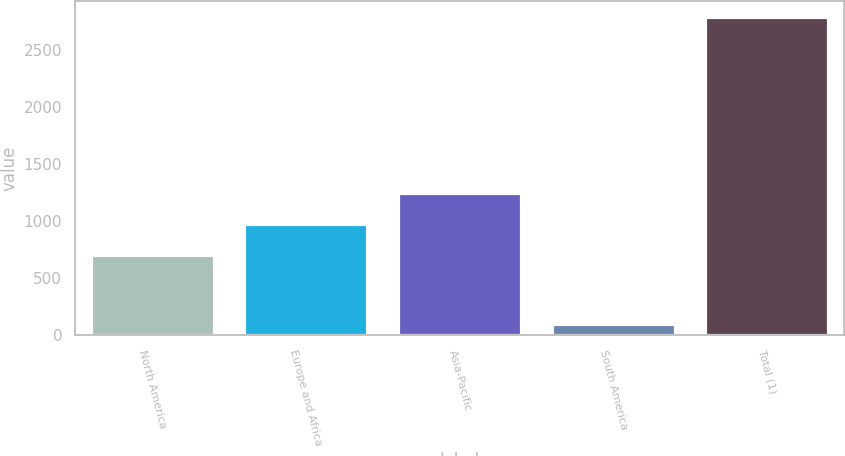Convert chart. <chart><loc_0><loc_0><loc_500><loc_500><bar_chart><fcel>North America<fcel>Europe and Africa<fcel>Asia-Pacific<fcel>South America<fcel>Total (1)<nl><fcel>708<fcel>977.3<fcel>1246.6<fcel>100<fcel>2793<nl></chart> 